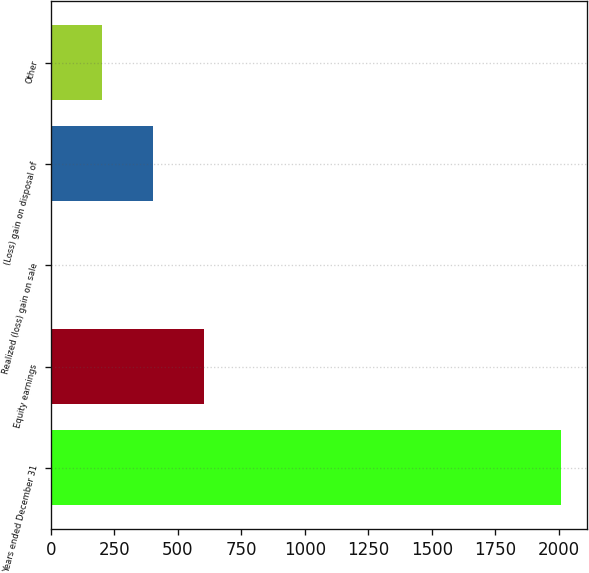<chart> <loc_0><loc_0><loc_500><loc_500><bar_chart><fcel>Years ended December 31<fcel>Equity earnings<fcel>Realized (loss) gain on sale<fcel>(Loss) gain on disposal of<fcel>Other<nl><fcel>2009<fcel>603.4<fcel>1<fcel>402.6<fcel>201.8<nl></chart> 